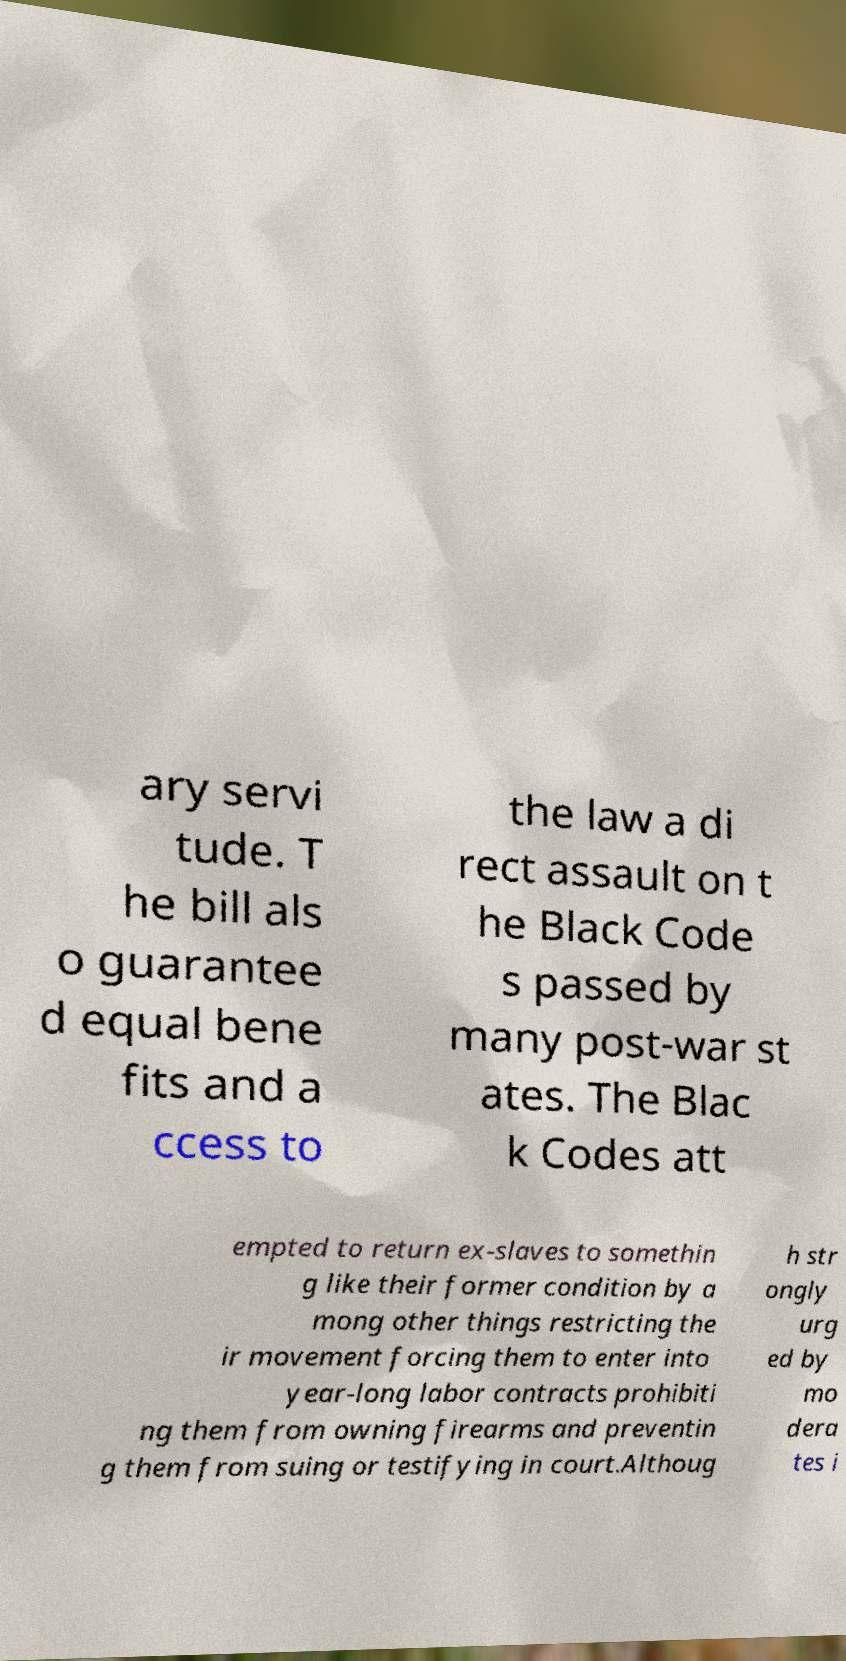Could you assist in decoding the text presented in this image and type it out clearly? ary servi tude. T he bill als o guarantee d equal bene fits and a ccess to the law a di rect assault on t he Black Code s passed by many post-war st ates. The Blac k Codes att empted to return ex-slaves to somethin g like their former condition by a mong other things restricting the ir movement forcing them to enter into year-long labor contracts prohibiti ng them from owning firearms and preventin g them from suing or testifying in court.Althoug h str ongly urg ed by mo dera tes i 